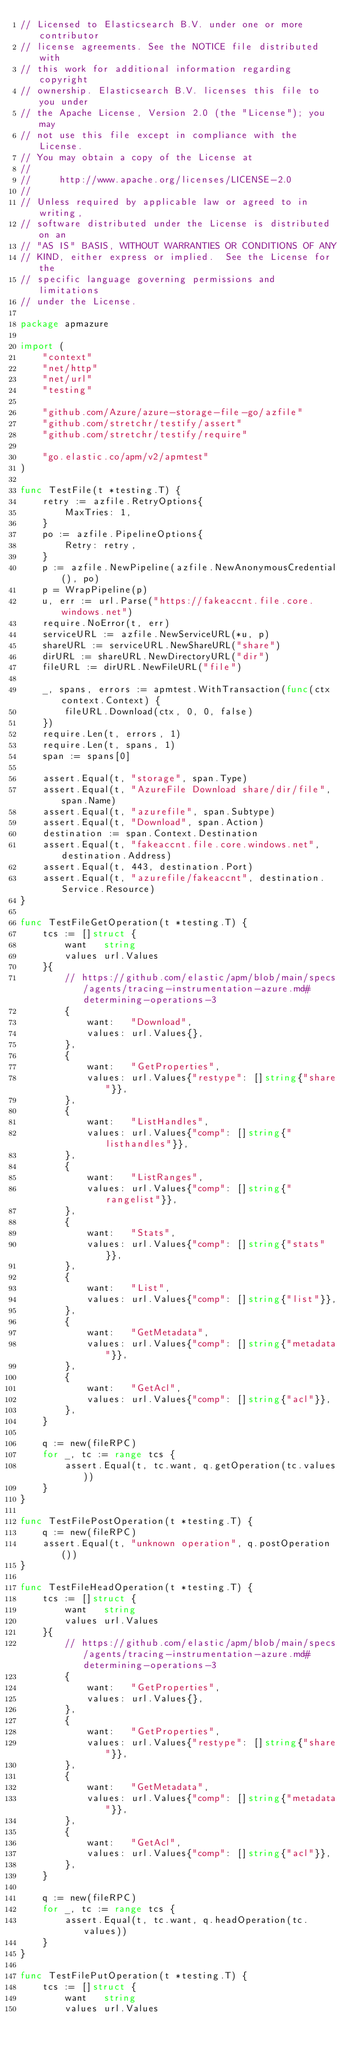<code> <loc_0><loc_0><loc_500><loc_500><_Go_>// Licensed to Elasticsearch B.V. under one or more contributor
// license agreements. See the NOTICE file distributed with
// this work for additional information regarding copyright
// ownership. Elasticsearch B.V. licenses this file to you under
// the Apache License, Version 2.0 (the "License"); you may
// not use this file except in compliance with the License.
// You may obtain a copy of the License at
//
//     http://www.apache.org/licenses/LICENSE-2.0
//
// Unless required by applicable law or agreed to in writing,
// software distributed under the License is distributed on an
// "AS IS" BASIS, WITHOUT WARRANTIES OR CONDITIONS OF ANY
// KIND, either express or implied.  See the License for the
// specific language governing permissions and limitations
// under the License.

package apmazure

import (
	"context"
	"net/http"
	"net/url"
	"testing"

	"github.com/Azure/azure-storage-file-go/azfile"
	"github.com/stretchr/testify/assert"
	"github.com/stretchr/testify/require"

	"go.elastic.co/apm/v2/apmtest"
)

func TestFile(t *testing.T) {
	retry := azfile.RetryOptions{
		MaxTries: 1,
	}
	po := azfile.PipelineOptions{
		Retry: retry,
	}
	p := azfile.NewPipeline(azfile.NewAnonymousCredential(), po)
	p = WrapPipeline(p)
	u, err := url.Parse("https://fakeaccnt.file.core.windows.net")
	require.NoError(t, err)
	serviceURL := azfile.NewServiceURL(*u, p)
	shareURL := serviceURL.NewShareURL("share")
	dirURL := shareURL.NewDirectoryURL("dir")
	fileURL := dirURL.NewFileURL("file")

	_, spans, errors := apmtest.WithTransaction(func(ctx context.Context) {
		fileURL.Download(ctx, 0, 0, false)
	})
	require.Len(t, errors, 1)
	require.Len(t, spans, 1)
	span := spans[0]

	assert.Equal(t, "storage", span.Type)
	assert.Equal(t, "AzureFile Download share/dir/file", span.Name)
	assert.Equal(t, "azurefile", span.Subtype)
	assert.Equal(t, "Download", span.Action)
	destination := span.Context.Destination
	assert.Equal(t, "fakeaccnt.file.core.windows.net", destination.Address)
	assert.Equal(t, 443, destination.Port)
	assert.Equal(t, "azurefile/fakeaccnt", destination.Service.Resource)
}

func TestFileGetOperation(t *testing.T) {
	tcs := []struct {
		want   string
		values url.Values
	}{
		// https://github.com/elastic/apm/blob/main/specs/agents/tracing-instrumentation-azure.md#determining-operations-3
		{
			want:   "Download",
			values: url.Values{},
		},
		{
			want:   "GetProperties",
			values: url.Values{"restype": []string{"share"}},
		},
		{
			want:   "ListHandles",
			values: url.Values{"comp": []string{"listhandles"}},
		},
		{
			want:   "ListRanges",
			values: url.Values{"comp": []string{"rangelist"}},
		},
		{
			want:   "Stats",
			values: url.Values{"comp": []string{"stats"}},
		},
		{
			want:   "List",
			values: url.Values{"comp": []string{"list"}},
		},
		{
			want:   "GetMetadata",
			values: url.Values{"comp": []string{"metadata"}},
		},
		{
			want:   "GetAcl",
			values: url.Values{"comp": []string{"acl"}},
		},
	}

	q := new(fileRPC)
	for _, tc := range tcs {
		assert.Equal(t, tc.want, q.getOperation(tc.values))
	}
}

func TestFilePostOperation(t *testing.T) {
	q := new(fileRPC)
	assert.Equal(t, "unknown operation", q.postOperation())
}

func TestFileHeadOperation(t *testing.T) {
	tcs := []struct {
		want   string
		values url.Values
	}{
		// https://github.com/elastic/apm/blob/main/specs/agents/tracing-instrumentation-azure.md#determining-operations-3
		{
			want:   "GetProperties",
			values: url.Values{},
		},
		{
			want:   "GetProperties",
			values: url.Values{"restype": []string{"share"}},
		},
		{
			want:   "GetMetadata",
			values: url.Values{"comp": []string{"metadata"}},
		},
		{
			want:   "GetAcl",
			values: url.Values{"comp": []string{"acl"}},
		},
	}

	q := new(fileRPC)
	for _, tc := range tcs {
		assert.Equal(t, tc.want, q.headOperation(tc.values))
	}
}

func TestFilePutOperation(t *testing.T) {
	tcs := []struct {
		want   string
		values url.Values</code> 